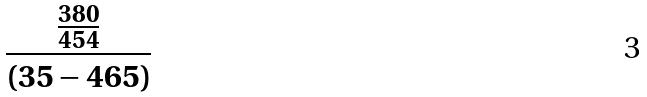Convert formula to latex. <formula><loc_0><loc_0><loc_500><loc_500>\frac { \frac { 3 8 0 } { 4 5 4 } } { ( 3 5 - 4 6 5 ) }</formula> 